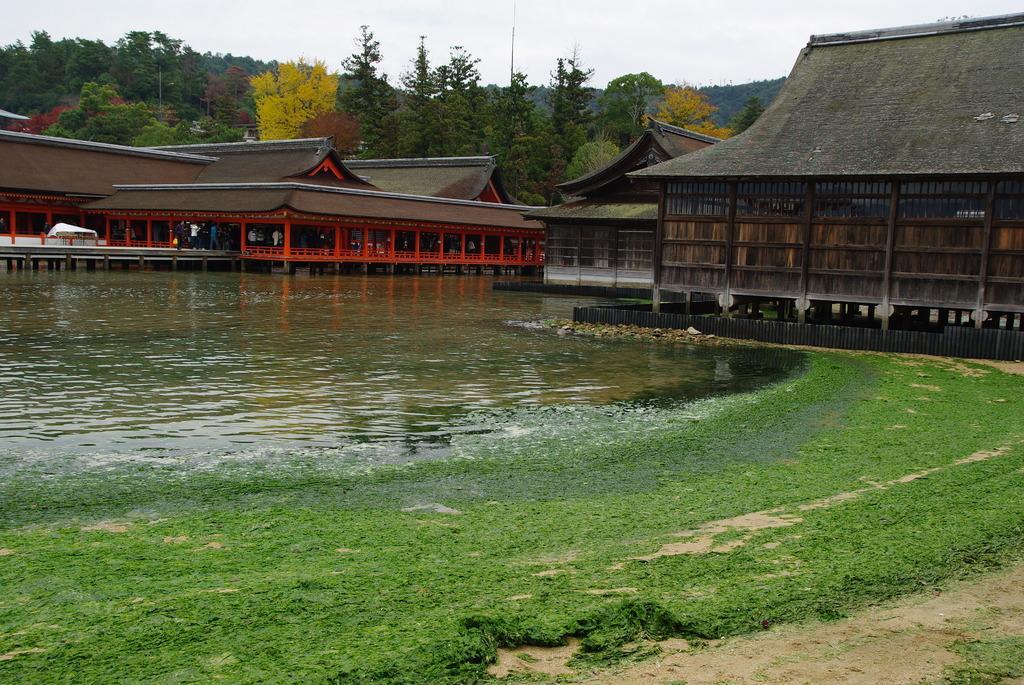Could you give a brief overview of what you see in this image? In this picture I can observe lake in the middle of the picture. In the bottom of the picture I can observe some grass on the ground. In the background there are buildings, trees and sky. 